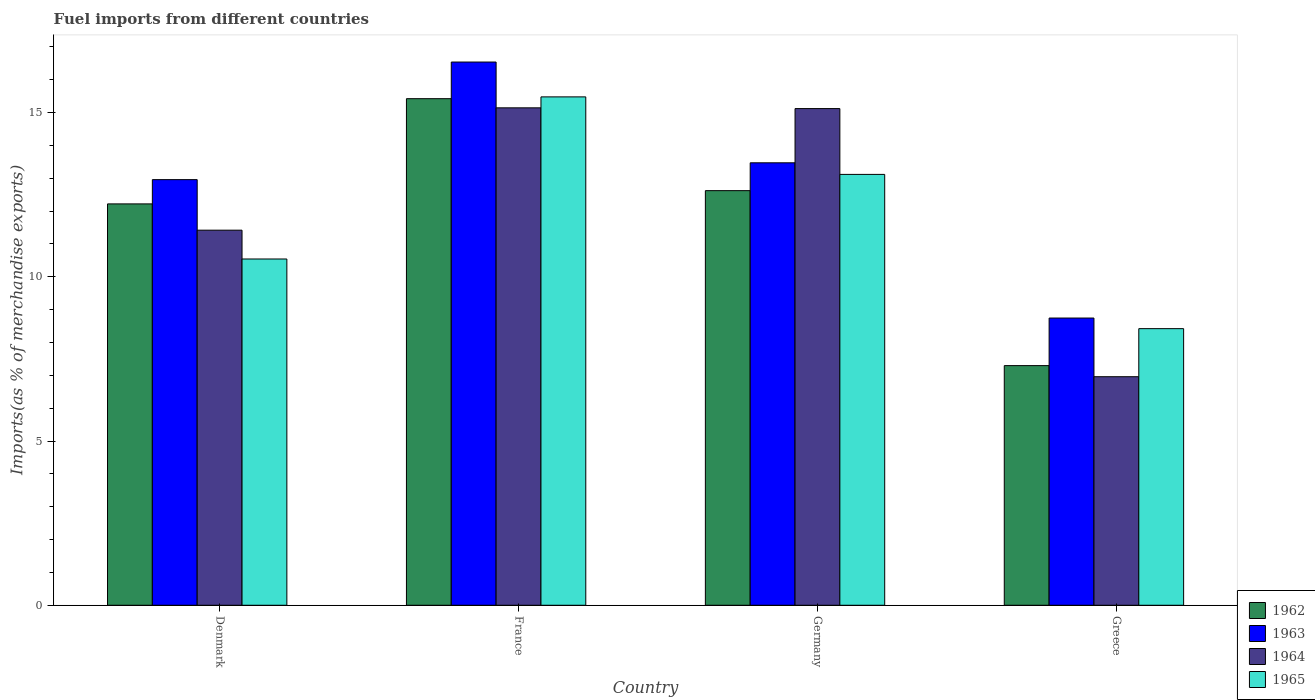How many different coloured bars are there?
Your answer should be very brief. 4. How many groups of bars are there?
Provide a short and direct response. 4. Are the number of bars per tick equal to the number of legend labels?
Your response must be concise. Yes. Are the number of bars on each tick of the X-axis equal?
Provide a short and direct response. Yes. How many bars are there on the 1st tick from the right?
Your answer should be very brief. 4. What is the label of the 3rd group of bars from the left?
Provide a short and direct response. Germany. What is the percentage of imports to different countries in 1965 in Denmark?
Offer a very short reply. 10.54. Across all countries, what is the maximum percentage of imports to different countries in 1964?
Keep it short and to the point. 15.14. Across all countries, what is the minimum percentage of imports to different countries in 1964?
Keep it short and to the point. 6.96. In which country was the percentage of imports to different countries in 1965 maximum?
Make the answer very short. France. In which country was the percentage of imports to different countries in 1963 minimum?
Ensure brevity in your answer.  Greece. What is the total percentage of imports to different countries in 1964 in the graph?
Your answer should be very brief. 48.64. What is the difference between the percentage of imports to different countries in 1965 in France and that in Greece?
Provide a succinct answer. 7.06. What is the difference between the percentage of imports to different countries in 1964 in Greece and the percentage of imports to different countries in 1965 in France?
Ensure brevity in your answer.  -8.52. What is the average percentage of imports to different countries in 1965 per country?
Your response must be concise. 11.89. What is the difference between the percentage of imports to different countries of/in 1964 and percentage of imports to different countries of/in 1962 in Greece?
Make the answer very short. -0.34. In how many countries, is the percentage of imports to different countries in 1963 greater than 5 %?
Your answer should be very brief. 4. What is the ratio of the percentage of imports to different countries in 1963 in France to that in Greece?
Offer a terse response. 1.89. Is the percentage of imports to different countries in 1962 in France less than that in Greece?
Ensure brevity in your answer.  No. Is the difference between the percentage of imports to different countries in 1964 in France and Germany greater than the difference between the percentage of imports to different countries in 1962 in France and Germany?
Provide a short and direct response. No. What is the difference between the highest and the second highest percentage of imports to different countries in 1962?
Your response must be concise. 0.4. What is the difference between the highest and the lowest percentage of imports to different countries in 1963?
Provide a succinct answer. 7.79. In how many countries, is the percentage of imports to different countries in 1962 greater than the average percentage of imports to different countries in 1962 taken over all countries?
Make the answer very short. 3. Is the sum of the percentage of imports to different countries in 1962 in Denmark and Germany greater than the maximum percentage of imports to different countries in 1963 across all countries?
Your answer should be compact. Yes. What does the 3rd bar from the left in Greece represents?
Your answer should be very brief. 1964. What does the 2nd bar from the right in France represents?
Ensure brevity in your answer.  1964. Is it the case that in every country, the sum of the percentage of imports to different countries in 1963 and percentage of imports to different countries in 1964 is greater than the percentage of imports to different countries in 1965?
Give a very brief answer. Yes. How many bars are there?
Provide a succinct answer. 16. How many countries are there in the graph?
Your response must be concise. 4. What is the difference between two consecutive major ticks on the Y-axis?
Offer a terse response. 5. Does the graph contain any zero values?
Your response must be concise. No. Does the graph contain grids?
Your response must be concise. No. What is the title of the graph?
Offer a very short reply. Fuel imports from different countries. What is the label or title of the Y-axis?
Ensure brevity in your answer.  Imports(as % of merchandise exports). What is the Imports(as % of merchandise exports) in 1962 in Denmark?
Keep it short and to the point. 12.22. What is the Imports(as % of merchandise exports) in 1963 in Denmark?
Provide a succinct answer. 12.96. What is the Imports(as % of merchandise exports) of 1964 in Denmark?
Make the answer very short. 11.42. What is the Imports(as % of merchandise exports) in 1965 in Denmark?
Offer a terse response. 10.54. What is the Imports(as % of merchandise exports) of 1962 in France?
Keep it short and to the point. 15.42. What is the Imports(as % of merchandise exports) in 1963 in France?
Keep it short and to the point. 16.54. What is the Imports(as % of merchandise exports) of 1964 in France?
Your answer should be compact. 15.14. What is the Imports(as % of merchandise exports) in 1965 in France?
Make the answer very short. 15.48. What is the Imports(as % of merchandise exports) of 1962 in Germany?
Offer a very short reply. 12.62. What is the Imports(as % of merchandise exports) of 1963 in Germany?
Give a very brief answer. 13.47. What is the Imports(as % of merchandise exports) in 1964 in Germany?
Provide a succinct answer. 15.12. What is the Imports(as % of merchandise exports) of 1965 in Germany?
Your answer should be compact. 13.12. What is the Imports(as % of merchandise exports) in 1962 in Greece?
Your response must be concise. 7.3. What is the Imports(as % of merchandise exports) of 1963 in Greece?
Offer a terse response. 8.74. What is the Imports(as % of merchandise exports) in 1964 in Greece?
Ensure brevity in your answer.  6.96. What is the Imports(as % of merchandise exports) in 1965 in Greece?
Your answer should be very brief. 8.42. Across all countries, what is the maximum Imports(as % of merchandise exports) in 1962?
Your answer should be very brief. 15.42. Across all countries, what is the maximum Imports(as % of merchandise exports) in 1963?
Keep it short and to the point. 16.54. Across all countries, what is the maximum Imports(as % of merchandise exports) in 1964?
Keep it short and to the point. 15.14. Across all countries, what is the maximum Imports(as % of merchandise exports) in 1965?
Ensure brevity in your answer.  15.48. Across all countries, what is the minimum Imports(as % of merchandise exports) in 1962?
Give a very brief answer. 7.3. Across all countries, what is the minimum Imports(as % of merchandise exports) of 1963?
Your answer should be compact. 8.74. Across all countries, what is the minimum Imports(as % of merchandise exports) of 1964?
Offer a terse response. 6.96. Across all countries, what is the minimum Imports(as % of merchandise exports) in 1965?
Ensure brevity in your answer.  8.42. What is the total Imports(as % of merchandise exports) of 1962 in the graph?
Make the answer very short. 47.56. What is the total Imports(as % of merchandise exports) in 1963 in the graph?
Keep it short and to the point. 51.71. What is the total Imports(as % of merchandise exports) in 1964 in the graph?
Ensure brevity in your answer.  48.64. What is the total Imports(as % of merchandise exports) of 1965 in the graph?
Keep it short and to the point. 47.56. What is the difference between the Imports(as % of merchandise exports) of 1962 in Denmark and that in France?
Your response must be concise. -3.2. What is the difference between the Imports(as % of merchandise exports) in 1963 in Denmark and that in France?
Provide a short and direct response. -3.58. What is the difference between the Imports(as % of merchandise exports) in 1964 in Denmark and that in France?
Make the answer very short. -3.72. What is the difference between the Imports(as % of merchandise exports) of 1965 in Denmark and that in France?
Provide a succinct answer. -4.94. What is the difference between the Imports(as % of merchandise exports) of 1962 in Denmark and that in Germany?
Give a very brief answer. -0.4. What is the difference between the Imports(as % of merchandise exports) of 1963 in Denmark and that in Germany?
Your response must be concise. -0.51. What is the difference between the Imports(as % of merchandise exports) of 1964 in Denmark and that in Germany?
Offer a terse response. -3.7. What is the difference between the Imports(as % of merchandise exports) in 1965 in Denmark and that in Germany?
Offer a terse response. -2.58. What is the difference between the Imports(as % of merchandise exports) in 1962 in Denmark and that in Greece?
Your answer should be very brief. 4.92. What is the difference between the Imports(as % of merchandise exports) in 1963 in Denmark and that in Greece?
Your response must be concise. 4.21. What is the difference between the Imports(as % of merchandise exports) in 1964 in Denmark and that in Greece?
Offer a very short reply. 4.46. What is the difference between the Imports(as % of merchandise exports) in 1965 in Denmark and that in Greece?
Provide a short and direct response. 2.12. What is the difference between the Imports(as % of merchandise exports) of 1962 in France and that in Germany?
Ensure brevity in your answer.  2.8. What is the difference between the Imports(as % of merchandise exports) of 1963 in France and that in Germany?
Make the answer very short. 3.07. What is the difference between the Imports(as % of merchandise exports) in 1964 in France and that in Germany?
Provide a succinct answer. 0.02. What is the difference between the Imports(as % of merchandise exports) of 1965 in France and that in Germany?
Offer a very short reply. 2.36. What is the difference between the Imports(as % of merchandise exports) in 1962 in France and that in Greece?
Provide a short and direct response. 8.13. What is the difference between the Imports(as % of merchandise exports) of 1963 in France and that in Greece?
Your answer should be compact. 7.79. What is the difference between the Imports(as % of merchandise exports) of 1964 in France and that in Greece?
Ensure brevity in your answer.  8.19. What is the difference between the Imports(as % of merchandise exports) in 1965 in France and that in Greece?
Your response must be concise. 7.06. What is the difference between the Imports(as % of merchandise exports) of 1962 in Germany and that in Greece?
Your answer should be compact. 5.33. What is the difference between the Imports(as % of merchandise exports) in 1963 in Germany and that in Greece?
Offer a terse response. 4.73. What is the difference between the Imports(as % of merchandise exports) in 1964 in Germany and that in Greece?
Make the answer very short. 8.16. What is the difference between the Imports(as % of merchandise exports) in 1965 in Germany and that in Greece?
Offer a terse response. 4.7. What is the difference between the Imports(as % of merchandise exports) of 1962 in Denmark and the Imports(as % of merchandise exports) of 1963 in France?
Keep it short and to the point. -4.32. What is the difference between the Imports(as % of merchandise exports) of 1962 in Denmark and the Imports(as % of merchandise exports) of 1964 in France?
Keep it short and to the point. -2.92. What is the difference between the Imports(as % of merchandise exports) in 1962 in Denmark and the Imports(as % of merchandise exports) in 1965 in France?
Your response must be concise. -3.26. What is the difference between the Imports(as % of merchandise exports) in 1963 in Denmark and the Imports(as % of merchandise exports) in 1964 in France?
Your answer should be very brief. -2.19. What is the difference between the Imports(as % of merchandise exports) in 1963 in Denmark and the Imports(as % of merchandise exports) in 1965 in France?
Provide a short and direct response. -2.52. What is the difference between the Imports(as % of merchandise exports) in 1964 in Denmark and the Imports(as % of merchandise exports) in 1965 in France?
Your answer should be very brief. -4.06. What is the difference between the Imports(as % of merchandise exports) in 1962 in Denmark and the Imports(as % of merchandise exports) in 1963 in Germany?
Make the answer very short. -1.25. What is the difference between the Imports(as % of merchandise exports) of 1962 in Denmark and the Imports(as % of merchandise exports) of 1964 in Germany?
Ensure brevity in your answer.  -2.9. What is the difference between the Imports(as % of merchandise exports) of 1962 in Denmark and the Imports(as % of merchandise exports) of 1965 in Germany?
Your answer should be very brief. -0.9. What is the difference between the Imports(as % of merchandise exports) of 1963 in Denmark and the Imports(as % of merchandise exports) of 1964 in Germany?
Ensure brevity in your answer.  -2.16. What is the difference between the Imports(as % of merchandise exports) of 1963 in Denmark and the Imports(as % of merchandise exports) of 1965 in Germany?
Offer a very short reply. -0.16. What is the difference between the Imports(as % of merchandise exports) of 1964 in Denmark and the Imports(as % of merchandise exports) of 1965 in Germany?
Offer a terse response. -1.7. What is the difference between the Imports(as % of merchandise exports) in 1962 in Denmark and the Imports(as % of merchandise exports) in 1963 in Greece?
Offer a terse response. 3.48. What is the difference between the Imports(as % of merchandise exports) of 1962 in Denmark and the Imports(as % of merchandise exports) of 1964 in Greece?
Provide a short and direct response. 5.26. What is the difference between the Imports(as % of merchandise exports) in 1962 in Denmark and the Imports(as % of merchandise exports) in 1965 in Greece?
Your response must be concise. 3.8. What is the difference between the Imports(as % of merchandise exports) in 1963 in Denmark and the Imports(as % of merchandise exports) in 1964 in Greece?
Make the answer very short. 6. What is the difference between the Imports(as % of merchandise exports) of 1963 in Denmark and the Imports(as % of merchandise exports) of 1965 in Greece?
Offer a terse response. 4.54. What is the difference between the Imports(as % of merchandise exports) in 1964 in Denmark and the Imports(as % of merchandise exports) in 1965 in Greece?
Offer a terse response. 3. What is the difference between the Imports(as % of merchandise exports) in 1962 in France and the Imports(as % of merchandise exports) in 1963 in Germany?
Your response must be concise. 1.95. What is the difference between the Imports(as % of merchandise exports) in 1962 in France and the Imports(as % of merchandise exports) in 1964 in Germany?
Provide a short and direct response. 0.3. What is the difference between the Imports(as % of merchandise exports) of 1962 in France and the Imports(as % of merchandise exports) of 1965 in Germany?
Keep it short and to the point. 2.31. What is the difference between the Imports(as % of merchandise exports) in 1963 in France and the Imports(as % of merchandise exports) in 1964 in Germany?
Provide a succinct answer. 1.42. What is the difference between the Imports(as % of merchandise exports) in 1963 in France and the Imports(as % of merchandise exports) in 1965 in Germany?
Make the answer very short. 3.42. What is the difference between the Imports(as % of merchandise exports) in 1964 in France and the Imports(as % of merchandise exports) in 1965 in Germany?
Your response must be concise. 2.03. What is the difference between the Imports(as % of merchandise exports) in 1962 in France and the Imports(as % of merchandise exports) in 1963 in Greece?
Offer a terse response. 6.68. What is the difference between the Imports(as % of merchandise exports) of 1962 in France and the Imports(as % of merchandise exports) of 1964 in Greece?
Make the answer very short. 8.46. What is the difference between the Imports(as % of merchandise exports) of 1962 in France and the Imports(as % of merchandise exports) of 1965 in Greece?
Your response must be concise. 7. What is the difference between the Imports(as % of merchandise exports) of 1963 in France and the Imports(as % of merchandise exports) of 1964 in Greece?
Offer a very short reply. 9.58. What is the difference between the Imports(as % of merchandise exports) of 1963 in France and the Imports(as % of merchandise exports) of 1965 in Greece?
Make the answer very short. 8.12. What is the difference between the Imports(as % of merchandise exports) of 1964 in France and the Imports(as % of merchandise exports) of 1965 in Greece?
Provide a short and direct response. 6.72. What is the difference between the Imports(as % of merchandise exports) of 1962 in Germany and the Imports(as % of merchandise exports) of 1963 in Greece?
Make the answer very short. 3.88. What is the difference between the Imports(as % of merchandise exports) in 1962 in Germany and the Imports(as % of merchandise exports) in 1964 in Greece?
Your response must be concise. 5.66. What is the difference between the Imports(as % of merchandise exports) of 1962 in Germany and the Imports(as % of merchandise exports) of 1965 in Greece?
Provide a succinct answer. 4.2. What is the difference between the Imports(as % of merchandise exports) in 1963 in Germany and the Imports(as % of merchandise exports) in 1964 in Greece?
Ensure brevity in your answer.  6.51. What is the difference between the Imports(as % of merchandise exports) of 1963 in Germany and the Imports(as % of merchandise exports) of 1965 in Greece?
Provide a short and direct response. 5.05. What is the difference between the Imports(as % of merchandise exports) of 1964 in Germany and the Imports(as % of merchandise exports) of 1965 in Greece?
Make the answer very short. 6.7. What is the average Imports(as % of merchandise exports) of 1962 per country?
Offer a very short reply. 11.89. What is the average Imports(as % of merchandise exports) of 1963 per country?
Give a very brief answer. 12.93. What is the average Imports(as % of merchandise exports) in 1964 per country?
Your answer should be compact. 12.16. What is the average Imports(as % of merchandise exports) in 1965 per country?
Give a very brief answer. 11.89. What is the difference between the Imports(as % of merchandise exports) of 1962 and Imports(as % of merchandise exports) of 1963 in Denmark?
Give a very brief answer. -0.74. What is the difference between the Imports(as % of merchandise exports) of 1962 and Imports(as % of merchandise exports) of 1964 in Denmark?
Your answer should be very brief. 0.8. What is the difference between the Imports(as % of merchandise exports) in 1962 and Imports(as % of merchandise exports) in 1965 in Denmark?
Ensure brevity in your answer.  1.68. What is the difference between the Imports(as % of merchandise exports) in 1963 and Imports(as % of merchandise exports) in 1964 in Denmark?
Your answer should be very brief. 1.54. What is the difference between the Imports(as % of merchandise exports) in 1963 and Imports(as % of merchandise exports) in 1965 in Denmark?
Ensure brevity in your answer.  2.42. What is the difference between the Imports(as % of merchandise exports) in 1964 and Imports(as % of merchandise exports) in 1965 in Denmark?
Keep it short and to the point. 0.88. What is the difference between the Imports(as % of merchandise exports) in 1962 and Imports(as % of merchandise exports) in 1963 in France?
Your response must be concise. -1.12. What is the difference between the Imports(as % of merchandise exports) of 1962 and Imports(as % of merchandise exports) of 1964 in France?
Offer a very short reply. 0.28. What is the difference between the Imports(as % of merchandise exports) in 1962 and Imports(as % of merchandise exports) in 1965 in France?
Ensure brevity in your answer.  -0.05. What is the difference between the Imports(as % of merchandise exports) in 1963 and Imports(as % of merchandise exports) in 1964 in France?
Your answer should be very brief. 1.39. What is the difference between the Imports(as % of merchandise exports) of 1963 and Imports(as % of merchandise exports) of 1965 in France?
Your answer should be compact. 1.06. What is the difference between the Imports(as % of merchandise exports) in 1964 and Imports(as % of merchandise exports) in 1965 in France?
Provide a short and direct response. -0.33. What is the difference between the Imports(as % of merchandise exports) in 1962 and Imports(as % of merchandise exports) in 1963 in Germany?
Provide a succinct answer. -0.85. What is the difference between the Imports(as % of merchandise exports) of 1962 and Imports(as % of merchandise exports) of 1964 in Germany?
Keep it short and to the point. -2.5. What is the difference between the Imports(as % of merchandise exports) of 1962 and Imports(as % of merchandise exports) of 1965 in Germany?
Offer a very short reply. -0.49. What is the difference between the Imports(as % of merchandise exports) in 1963 and Imports(as % of merchandise exports) in 1964 in Germany?
Keep it short and to the point. -1.65. What is the difference between the Imports(as % of merchandise exports) of 1963 and Imports(as % of merchandise exports) of 1965 in Germany?
Provide a succinct answer. 0.35. What is the difference between the Imports(as % of merchandise exports) in 1964 and Imports(as % of merchandise exports) in 1965 in Germany?
Your answer should be very brief. 2. What is the difference between the Imports(as % of merchandise exports) in 1962 and Imports(as % of merchandise exports) in 1963 in Greece?
Offer a very short reply. -1.45. What is the difference between the Imports(as % of merchandise exports) of 1962 and Imports(as % of merchandise exports) of 1964 in Greece?
Your answer should be very brief. 0.34. What is the difference between the Imports(as % of merchandise exports) in 1962 and Imports(as % of merchandise exports) in 1965 in Greece?
Ensure brevity in your answer.  -1.13. What is the difference between the Imports(as % of merchandise exports) of 1963 and Imports(as % of merchandise exports) of 1964 in Greece?
Offer a very short reply. 1.79. What is the difference between the Imports(as % of merchandise exports) of 1963 and Imports(as % of merchandise exports) of 1965 in Greece?
Give a very brief answer. 0.32. What is the difference between the Imports(as % of merchandise exports) of 1964 and Imports(as % of merchandise exports) of 1965 in Greece?
Provide a short and direct response. -1.46. What is the ratio of the Imports(as % of merchandise exports) of 1962 in Denmark to that in France?
Your response must be concise. 0.79. What is the ratio of the Imports(as % of merchandise exports) in 1963 in Denmark to that in France?
Give a very brief answer. 0.78. What is the ratio of the Imports(as % of merchandise exports) in 1964 in Denmark to that in France?
Your response must be concise. 0.75. What is the ratio of the Imports(as % of merchandise exports) of 1965 in Denmark to that in France?
Keep it short and to the point. 0.68. What is the ratio of the Imports(as % of merchandise exports) of 1962 in Denmark to that in Germany?
Give a very brief answer. 0.97. What is the ratio of the Imports(as % of merchandise exports) of 1963 in Denmark to that in Germany?
Ensure brevity in your answer.  0.96. What is the ratio of the Imports(as % of merchandise exports) of 1964 in Denmark to that in Germany?
Provide a succinct answer. 0.76. What is the ratio of the Imports(as % of merchandise exports) in 1965 in Denmark to that in Germany?
Give a very brief answer. 0.8. What is the ratio of the Imports(as % of merchandise exports) in 1962 in Denmark to that in Greece?
Keep it short and to the point. 1.67. What is the ratio of the Imports(as % of merchandise exports) in 1963 in Denmark to that in Greece?
Provide a short and direct response. 1.48. What is the ratio of the Imports(as % of merchandise exports) in 1964 in Denmark to that in Greece?
Ensure brevity in your answer.  1.64. What is the ratio of the Imports(as % of merchandise exports) of 1965 in Denmark to that in Greece?
Provide a succinct answer. 1.25. What is the ratio of the Imports(as % of merchandise exports) of 1962 in France to that in Germany?
Give a very brief answer. 1.22. What is the ratio of the Imports(as % of merchandise exports) in 1963 in France to that in Germany?
Your response must be concise. 1.23. What is the ratio of the Imports(as % of merchandise exports) in 1965 in France to that in Germany?
Offer a very short reply. 1.18. What is the ratio of the Imports(as % of merchandise exports) of 1962 in France to that in Greece?
Your response must be concise. 2.11. What is the ratio of the Imports(as % of merchandise exports) of 1963 in France to that in Greece?
Your answer should be very brief. 1.89. What is the ratio of the Imports(as % of merchandise exports) in 1964 in France to that in Greece?
Your response must be concise. 2.18. What is the ratio of the Imports(as % of merchandise exports) in 1965 in France to that in Greece?
Offer a very short reply. 1.84. What is the ratio of the Imports(as % of merchandise exports) of 1962 in Germany to that in Greece?
Ensure brevity in your answer.  1.73. What is the ratio of the Imports(as % of merchandise exports) of 1963 in Germany to that in Greece?
Make the answer very short. 1.54. What is the ratio of the Imports(as % of merchandise exports) in 1964 in Germany to that in Greece?
Offer a very short reply. 2.17. What is the ratio of the Imports(as % of merchandise exports) in 1965 in Germany to that in Greece?
Your answer should be very brief. 1.56. What is the difference between the highest and the second highest Imports(as % of merchandise exports) in 1962?
Your answer should be very brief. 2.8. What is the difference between the highest and the second highest Imports(as % of merchandise exports) in 1963?
Give a very brief answer. 3.07. What is the difference between the highest and the second highest Imports(as % of merchandise exports) of 1964?
Offer a very short reply. 0.02. What is the difference between the highest and the second highest Imports(as % of merchandise exports) in 1965?
Offer a very short reply. 2.36. What is the difference between the highest and the lowest Imports(as % of merchandise exports) in 1962?
Offer a terse response. 8.13. What is the difference between the highest and the lowest Imports(as % of merchandise exports) of 1963?
Your answer should be very brief. 7.79. What is the difference between the highest and the lowest Imports(as % of merchandise exports) in 1964?
Give a very brief answer. 8.19. What is the difference between the highest and the lowest Imports(as % of merchandise exports) of 1965?
Ensure brevity in your answer.  7.06. 